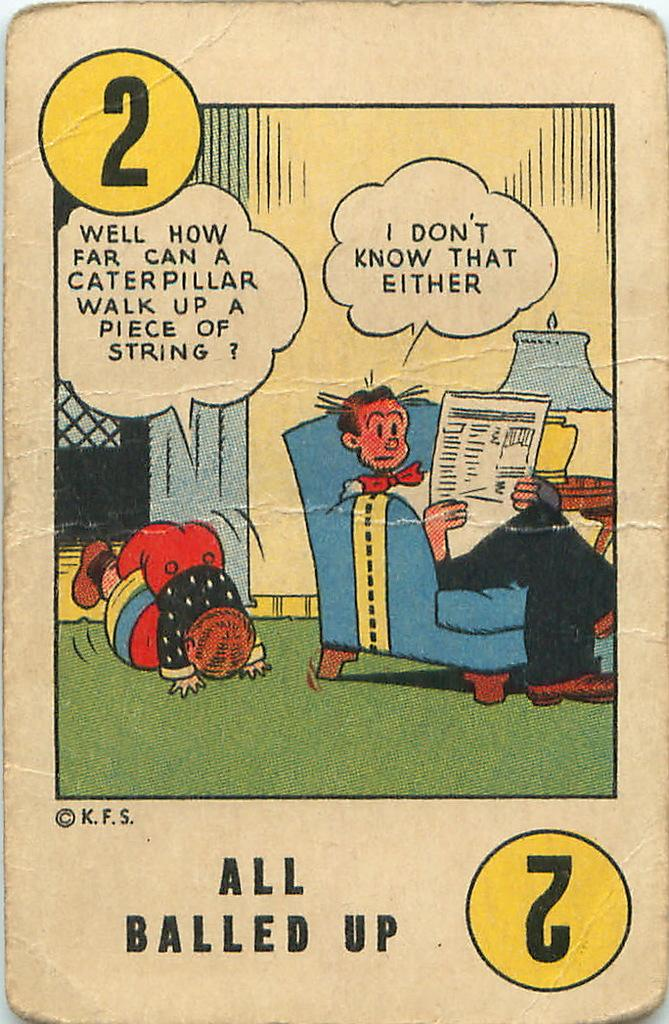What is depicted on the card in the picture? There is a card with an image of two persons in the picture. What can be seen in the background of the picture? There is a wall in the picture. What object is present in the picture that can be used for playing? There is a ball in the picture. What piece of furniture is in the picture? There is a chair in the picture. What is the source of light in the picture? There is a lamp on a table in the picture. What additional information is present on the card? The card has words and numbers on it. What type of animal is playing basketball in the picture? There is no animal or basketball present in the picture. What is the name of the thing that is not in the picture? It is impossible to name something that is not present in the image. 